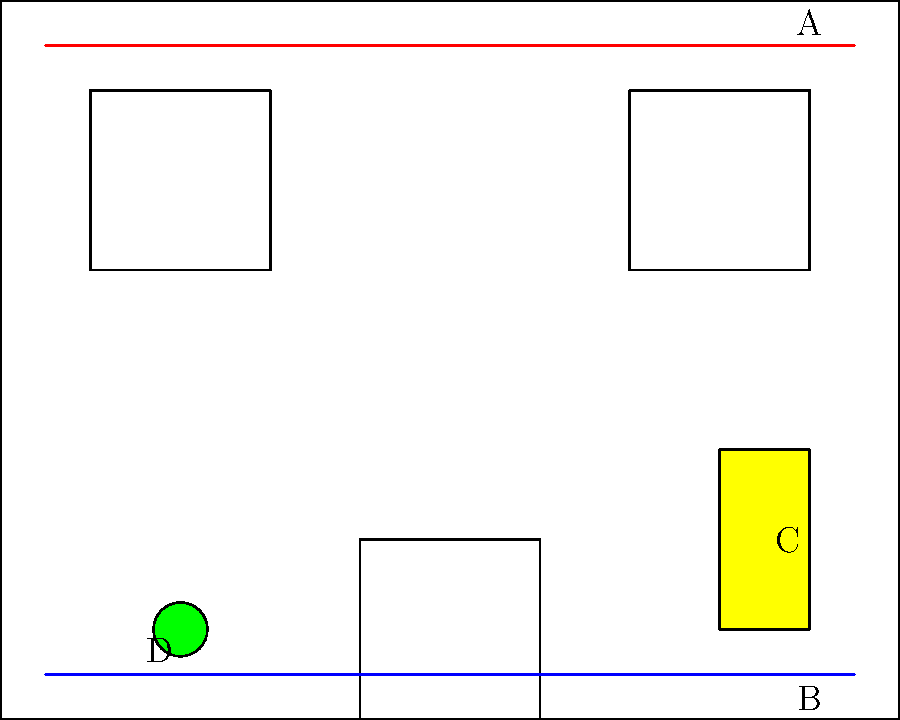In this cross-section view of a building, identify the most critical potential hazard that could escalate a fire situation rapidly. Label your choice (A, B, C, or D). To identify the most critical potential hazard, let's analyze each labeled element:

1. A (Red line at the top): This represents electrical wiring. While faulty wiring can cause fires, it's not typically the most rapid escalator in an existing fire situation.

2. B (Blue line at the bottom): This is likely a gas line. Gas leaks can lead to rapid fire spread and explosions, making this a severe hazard.

3. C (Yellow box on the right): This appears to be a storage area for flammable materials. Such materials can quickly intensify a fire, causing rapid spread.

4. D (Green circle on the left): This is likely a fire extinguisher, which is a safety measure rather than a hazard.

Among these, the gas line (B) poses the most critical and immediate danger in an active fire situation. A compromised gas line can lead to:

1. Rapid fire spread throughout the structure
2. Potential explosions
3. Intensification of the existing fire
4. Creation of new fire sources

While flammable materials storage (C) is also hazardous, a gas line breach would typically lead to more immediate and widespread danger.
Answer: B 